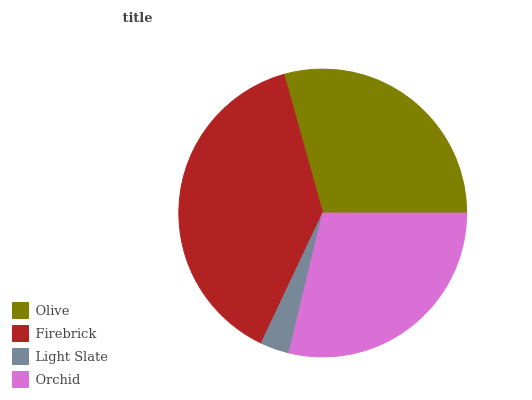Is Light Slate the minimum?
Answer yes or no. Yes. Is Firebrick the maximum?
Answer yes or no. Yes. Is Firebrick the minimum?
Answer yes or no. No. Is Light Slate the maximum?
Answer yes or no. No. Is Firebrick greater than Light Slate?
Answer yes or no. Yes. Is Light Slate less than Firebrick?
Answer yes or no. Yes. Is Light Slate greater than Firebrick?
Answer yes or no. No. Is Firebrick less than Light Slate?
Answer yes or no. No. Is Olive the high median?
Answer yes or no. Yes. Is Orchid the low median?
Answer yes or no. Yes. Is Firebrick the high median?
Answer yes or no. No. Is Light Slate the low median?
Answer yes or no. No. 